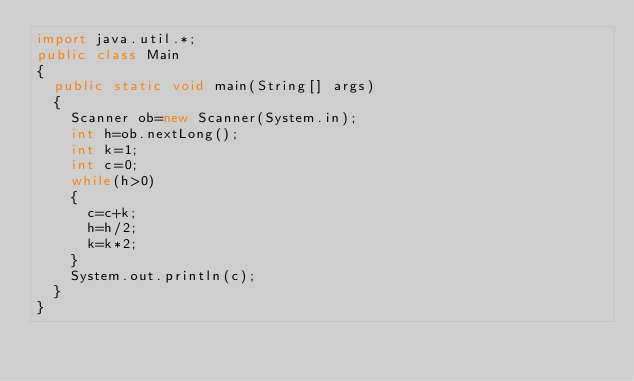Convert code to text. <code><loc_0><loc_0><loc_500><loc_500><_Java_>import java.util.*;
public class Main
{
  public static void main(String[] args)
  {
    Scanner ob=new Scanner(System.in);
    int h=ob.nextLong();
    int k=1;
    int c=0;
    while(h>0)
    {
      c=c+k;
      h=h/2;
      k=k*2;
    }
    System.out.println(c);
  }
}</code> 